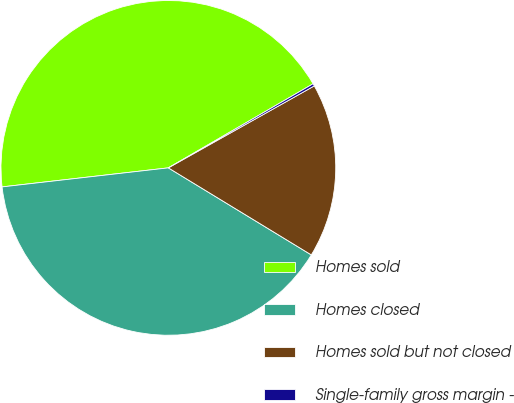Convert chart. <chart><loc_0><loc_0><loc_500><loc_500><pie_chart><fcel>Homes sold<fcel>Homes closed<fcel>Homes sold but not closed<fcel>Single-family gross margin -<nl><fcel>43.44%<fcel>39.48%<fcel>16.85%<fcel>0.23%<nl></chart> 